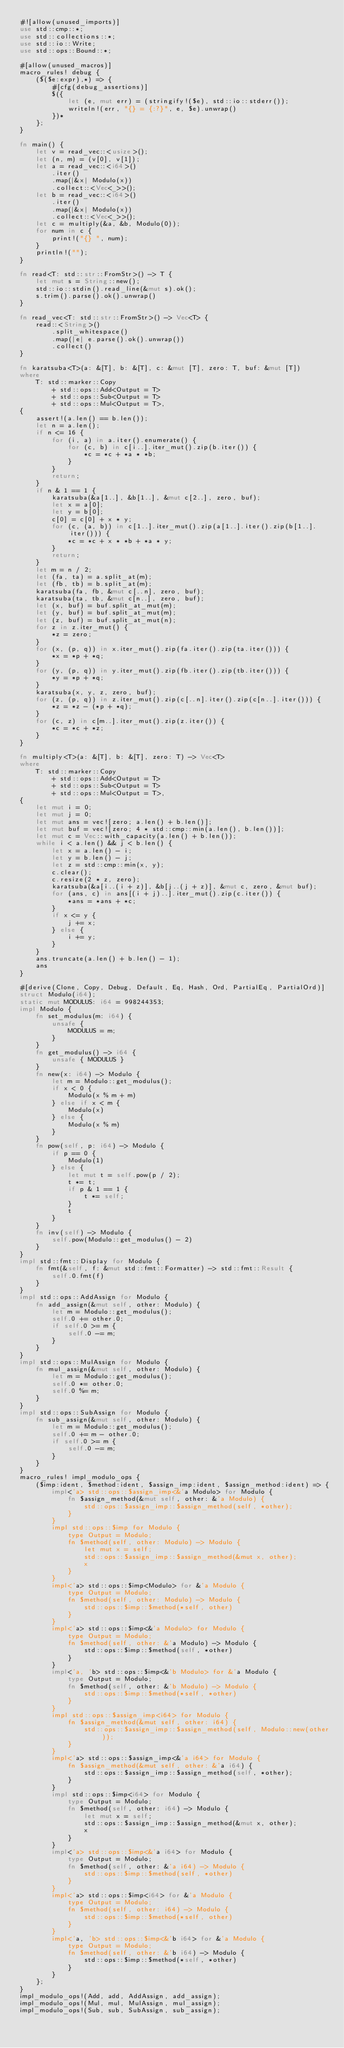Convert code to text. <code><loc_0><loc_0><loc_500><loc_500><_Rust_>#![allow(unused_imports)]
use std::cmp::*;
use std::collections::*;
use std::io::Write;
use std::ops::Bound::*;

#[allow(unused_macros)]
macro_rules! debug {
    ($($e:expr),*) => {
        #[cfg(debug_assertions)]
        $({
            let (e, mut err) = (stringify!($e), std::io::stderr());
            writeln!(err, "{} = {:?}", e, $e).unwrap()
        })*
    };
}

fn main() {
    let v = read_vec::<usize>();
    let (n, m) = (v[0], v[1]);
    let a = read_vec::<i64>()
        .iter()
        .map(|&x| Modulo(x))
        .collect::<Vec<_>>();
    let b = read_vec::<i64>()
        .iter()
        .map(|&x| Modulo(x))
        .collect::<Vec<_>>();
    let c = multiply(&a, &b, Modulo(0));
    for num in c {
        print!("{} ", num);
    }
    println!("");
}

fn read<T: std::str::FromStr>() -> T {
    let mut s = String::new();
    std::io::stdin().read_line(&mut s).ok();
    s.trim().parse().ok().unwrap()
}

fn read_vec<T: std::str::FromStr>() -> Vec<T> {
    read::<String>()
        .split_whitespace()
        .map(|e| e.parse().ok().unwrap())
        .collect()
}

fn karatsuba<T>(a: &[T], b: &[T], c: &mut [T], zero: T, buf: &mut [T])
where
    T: std::marker::Copy
        + std::ops::Add<Output = T>
        + std::ops::Sub<Output = T>
        + std::ops::Mul<Output = T>,
{
    assert!(a.len() == b.len());
    let n = a.len();
    if n <= 16 {
        for (i, a) in a.iter().enumerate() {
            for (c, b) in c[i..].iter_mut().zip(b.iter()) {
                *c = *c + *a * *b;
            }
        }
        return;
    }
    if n & 1 == 1 {
        karatsuba(&a[1..], &b[1..], &mut c[2..], zero, buf);
        let x = a[0];
        let y = b[0];
        c[0] = c[0] + x * y;
        for (c, (a, b)) in c[1..].iter_mut().zip(a[1..].iter().zip(b[1..].iter())) {
            *c = *c + x * *b + *a * y;
        }
        return;
    }
    let m = n / 2;
    let (fa, ta) = a.split_at(m);
    let (fb, tb) = b.split_at(m);
    karatsuba(fa, fb, &mut c[..n], zero, buf);
    karatsuba(ta, tb, &mut c[n..], zero, buf);
    let (x, buf) = buf.split_at_mut(m);
    let (y, buf) = buf.split_at_mut(m);
    let (z, buf) = buf.split_at_mut(n);
    for z in z.iter_mut() {
        *z = zero;
    }
    for (x, (p, q)) in x.iter_mut().zip(fa.iter().zip(ta.iter())) {
        *x = *p + *q;
    }
    for (y, (p, q)) in y.iter_mut().zip(fb.iter().zip(tb.iter())) {
        *y = *p + *q;
    }
    karatsuba(x, y, z, zero, buf);
    for (z, (p, q)) in z.iter_mut().zip(c[..n].iter().zip(c[n..].iter())) {
        *z = *z - (*p + *q);
    }
    for (c, z) in c[m..].iter_mut().zip(z.iter()) {
        *c = *c + *z;
    }
}

fn multiply<T>(a: &[T], b: &[T], zero: T) -> Vec<T>
where
    T: std::marker::Copy
        + std::ops::Add<Output = T>
        + std::ops::Sub<Output = T>
        + std::ops::Mul<Output = T>,
{
    let mut i = 0;
    let mut j = 0;
    let mut ans = vec![zero; a.len() + b.len()];
    let mut buf = vec![zero; 4 * std::cmp::min(a.len(), b.len())];
    let mut c = Vec::with_capacity(a.len() + b.len());
    while i < a.len() && j < b.len() {
        let x = a.len() - i;
        let y = b.len() - j;
        let z = std::cmp::min(x, y);
        c.clear();
        c.resize(2 * z, zero);
        karatsuba(&a[i..(i + z)], &b[j..(j + z)], &mut c, zero, &mut buf);
        for (ans, c) in ans[(i + j)..].iter_mut().zip(c.iter()) {
            *ans = *ans + *c;
        }
        if x <= y {
            j += x;
        } else {
            i += y;
        }
    }
    ans.truncate(a.len() + b.len() - 1);
    ans
}

#[derive(Clone, Copy, Debug, Default, Eq, Hash, Ord, PartialEq, PartialOrd)]
struct Modulo(i64);
static mut MODULUS: i64 = 998244353;
impl Modulo {
    fn set_modulus(m: i64) {
        unsafe {
            MODULUS = m;
        }
    }
    fn get_modulus() -> i64 {
        unsafe { MODULUS }
    }
    fn new(x: i64) -> Modulo {
        let m = Modulo::get_modulus();
        if x < 0 {
            Modulo(x % m + m)
        } else if x < m {
            Modulo(x)
        } else {
            Modulo(x % m)
        }
    }
    fn pow(self, p: i64) -> Modulo {
        if p == 0 {
            Modulo(1)
        } else {
            let mut t = self.pow(p / 2);
            t *= t;
            if p & 1 == 1 {
                t *= self;
            }
            t
        }
    }
    fn inv(self) -> Modulo {
        self.pow(Modulo::get_modulus() - 2)
    }
}
impl std::fmt::Display for Modulo {
    fn fmt(&self, f: &mut std::fmt::Formatter) -> std::fmt::Result {
        self.0.fmt(f)
    }
}
impl std::ops::AddAssign for Modulo {
    fn add_assign(&mut self, other: Modulo) {
        let m = Modulo::get_modulus();
        self.0 += other.0;
        if self.0 >= m {
            self.0 -= m;
        }
    }
}
impl std::ops::MulAssign for Modulo {
    fn mul_assign(&mut self, other: Modulo) {
        let m = Modulo::get_modulus();
        self.0 *= other.0;
        self.0 %= m;
    }
}
impl std::ops::SubAssign for Modulo {
    fn sub_assign(&mut self, other: Modulo) {
        let m = Modulo::get_modulus();
        self.0 += m - other.0;
        if self.0 >= m {
            self.0 -= m;
        }
    }
}
macro_rules! impl_modulo_ops {
    ($imp:ident, $method:ident, $assign_imp:ident, $assign_method:ident) => {
        impl<'a> std::ops::$assign_imp<&'a Modulo> for Modulo {
            fn $assign_method(&mut self, other: &'a Modulo) {
                std::ops::$assign_imp::$assign_method(self, *other);
            }
        }
        impl std::ops::$imp for Modulo {
            type Output = Modulo;
            fn $method(self, other: Modulo) -> Modulo {
                let mut x = self;
                std::ops::$assign_imp::$assign_method(&mut x, other);
                x
            }
        }
        impl<'a> std::ops::$imp<Modulo> for &'a Modulo {
            type Output = Modulo;
            fn $method(self, other: Modulo) -> Modulo {
                std::ops::$imp::$method(*self, other)
            }
        }
        impl<'a> std::ops::$imp<&'a Modulo> for Modulo {
            type Output = Modulo;
            fn $method(self, other: &'a Modulo) -> Modulo {
                std::ops::$imp::$method(self, *other)
            }
        }
        impl<'a, 'b> std::ops::$imp<&'b Modulo> for &'a Modulo {
            type Output = Modulo;
            fn $method(self, other: &'b Modulo) -> Modulo {
                std::ops::$imp::$method(*self, *other)
            }
        }
        impl std::ops::$assign_imp<i64> for Modulo {
            fn $assign_method(&mut self, other: i64) {
                std::ops::$assign_imp::$assign_method(self, Modulo::new(other));
            }
        }
        impl<'a> std::ops::$assign_imp<&'a i64> for Modulo {
            fn $assign_method(&mut self, other: &'a i64) {
                std::ops::$assign_imp::$assign_method(self, *other);
            }
        }
        impl std::ops::$imp<i64> for Modulo {
            type Output = Modulo;
            fn $method(self, other: i64) -> Modulo {
                let mut x = self;
                std::ops::$assign_imp::$assign_method(&mut x, other);
                x
            }
        }
        impl<'a> std::ops::$imp<&'a i64> for Modulo {
            type Output = Modulo;
            fn $method(self, other: &'a i64) -> Modulo {
                std::ops::$imp::$method(self, *other)
            }
        }
        impl<'a> std::ops::$imp<i64> for &'a Modulo {
            type Output = Modulo;
            fn $method(self, other: i64) -> Modulo {
                std::ops::$imp::$method(*self, other)
            }
        }
        impl<'a, 'b> std::ops::$imp<&'b i64> for &'a Modulo {
            type Output = Modulo;
            fn $method(self, other: &'b i64) -> Modulo {
                std::ops::$imp::$method(*self, *other)
            }
        }
    };
}
impl_modulo_ops!(Add, add, AddAssign, add_assign);
impl_modulo_ops!(Mul, mul, MulAssign, mul_assign);
impl_modulo_ops!(Sub, sub, SubAssign, sub_assign);
</code> 